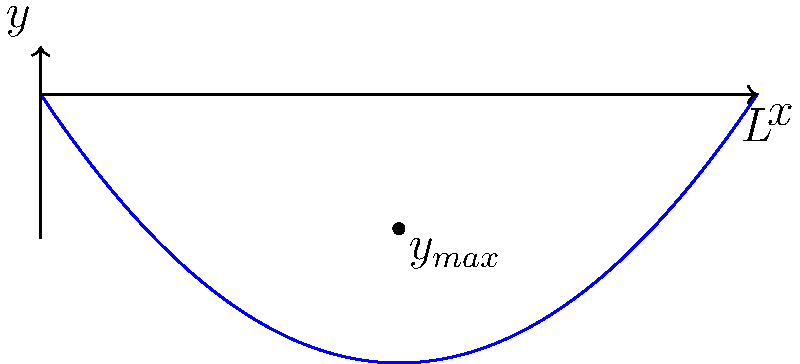In the context of trauma therapy, understanding structural stability can be metaphorically applied to emotional resilience. Consider a simply supported bridge of length $L$ under a moving load. At which point along the span does the maximum deflection occur, and how does this relate to the concept of emotional support in trauma recovery? To understand this problem, let's break it down step-by-step:

1) For a simply supported beam under a uniformly distributed load, the deflection curve is approximated by a parabola.

2) The equation of the deflection curve is given by:

   $$y = -\frac{wx}{24EI}(L^3 - 2Lx^2 + x^3)$$

   where $w$ is the load per unit length, $E$ is the modulus of elasticity, $I$ is the moment of inertia, and $L$ is the length of the beam.

3) To find the point of maximum deflection, we need to differentiate $y$ with respect to $x$ and set it to zero:

   $$\frac{dy}{dx} = -\frac{w}{24EI}(L^3 - 6Lx^2 + 3x^3) = 0$$

4) Solving this equation:

   $$L^3 - 6Lx^2 + 3x^3 = 0$$
   $$3x^3 - 6Lx^2 + L^3 = 0$$
   $$x^2(3x - 6L) + L^3 = 0$$
   $$x^2(x - 2L) + \frac{L^3}{3} = 0$$

5) The solution to this equation is $x = \frac{L}{2}$, which means the maximum deflection occurs at the midpoint of the beam.

In the context of trauma therapy, this can be metaphorically related to emotional support. Just as the bridge needs the strongest support at its midpoint to prevent maximum deflection, individuals recovering from trauma often need the most support at the "midpoint" of their healing journey. This is when they're processing the most difficult emotions and memories, and when the risk of "emotional deflection" or setback is highest.
Answer: Maximum deflection occurs at $\frac{L}{2}$, midpoint of the span. 